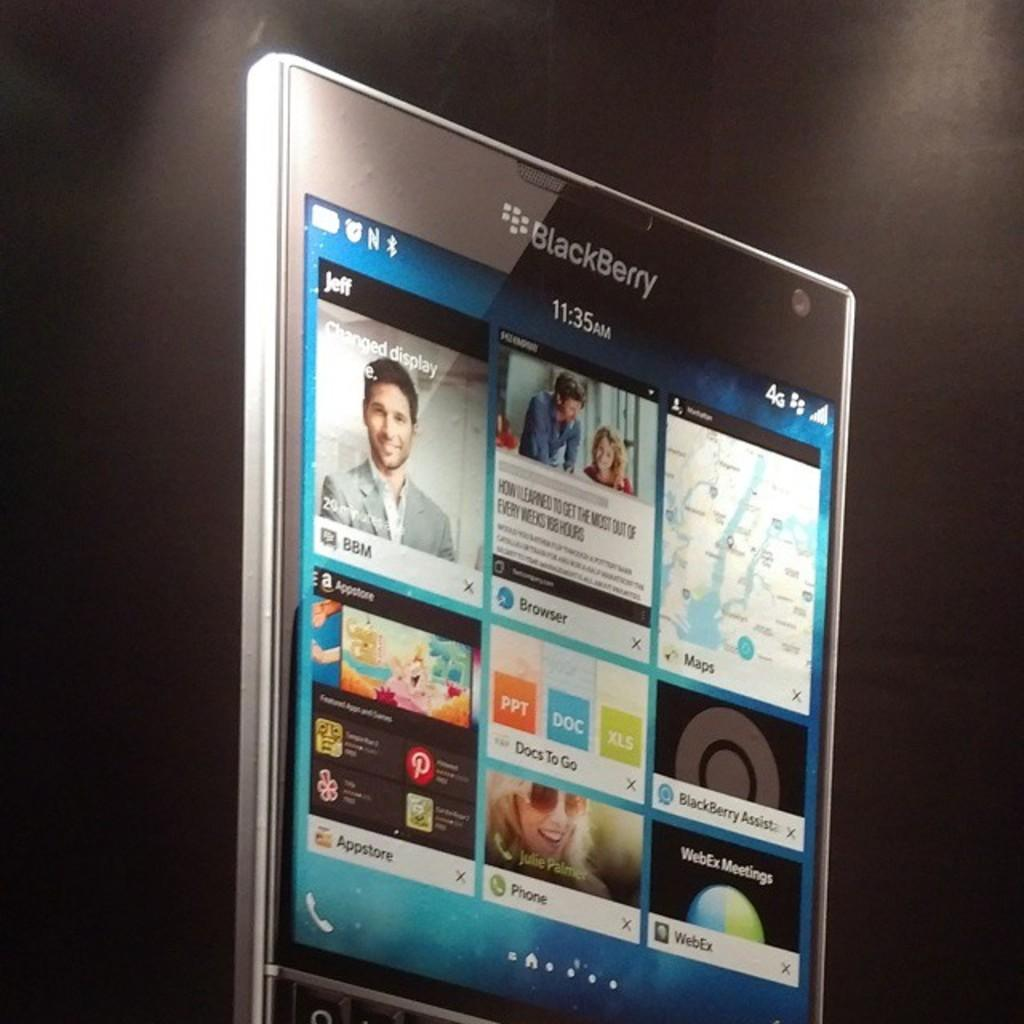<image>
Write a terse but informative summary of the picture. An advertisement for the new BlackBerry device against a black background. 